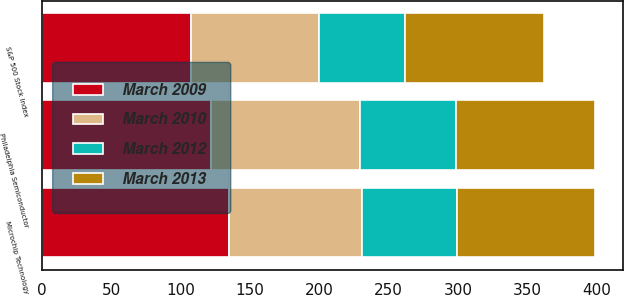<chart> <loc_0><loc_0><loc_500><loc_500><stacked_bar_chart><ecel><fcel>Microchip Technology<fcel>S&P 500 Stock Index<fcel>Philadelphia Semiconductor<nl><fcel>March 2013<fcel>100<fcel>100<fcel>100<nl><fcel>March 2012<fcel>68.31<fcel>61.91<fcel>69.61<nl><fcel>March 2010<fcel>95.81<fcel>92.72<fcel>107.23<nl><fcel>March 2009<fcel>135.12<fcel>107.23<fcel>122.1<nl></chart> 